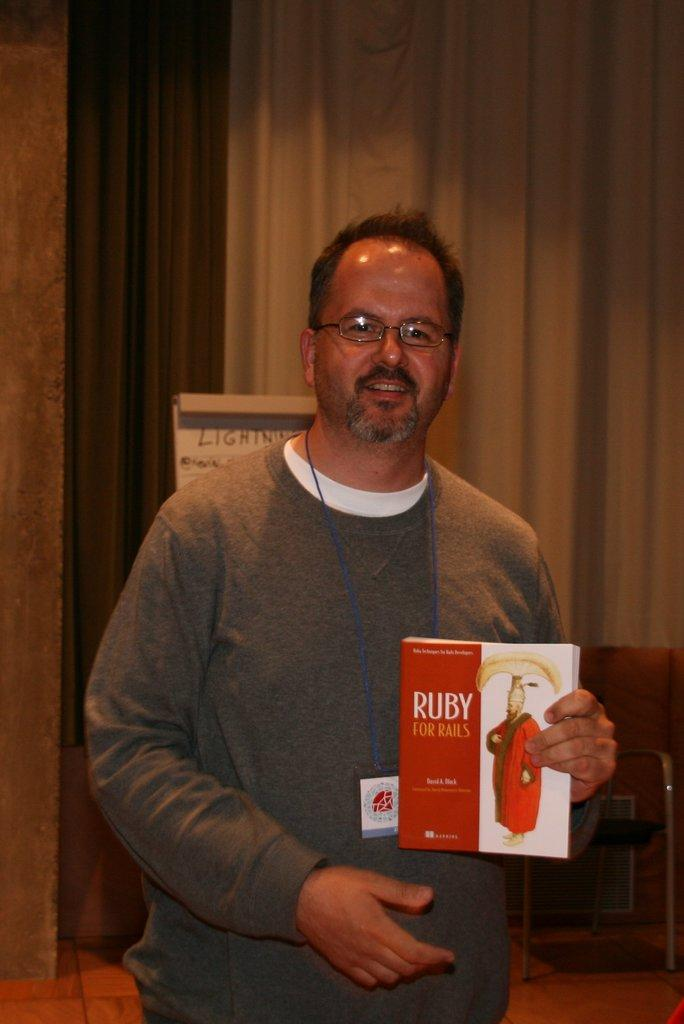Provide a one-sentence caption for the provided image. A man holds a textbook on the coding language Ruby. 